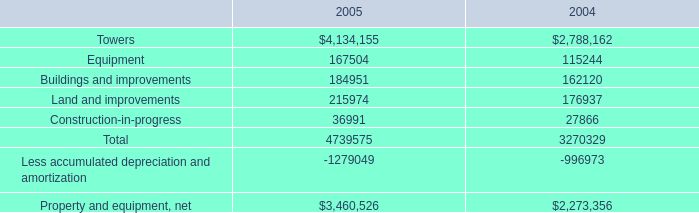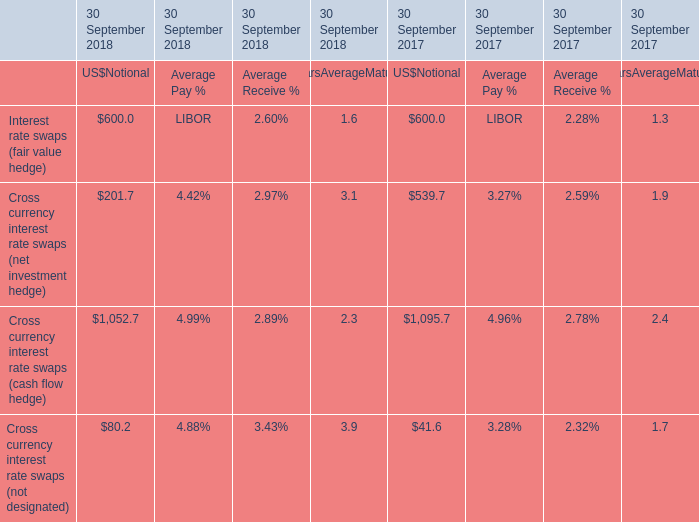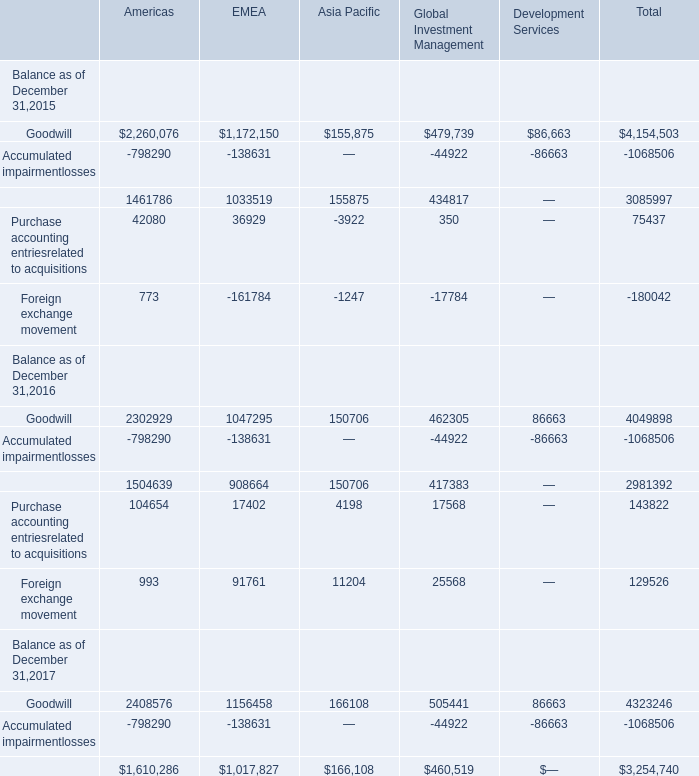What's the average of Property and equipment, net of 2004, and Foreign exchange movement of EMEA ? 
Computations: ((2273356.0 + 161784.0) / 2)
Answer: 1217570.0. 